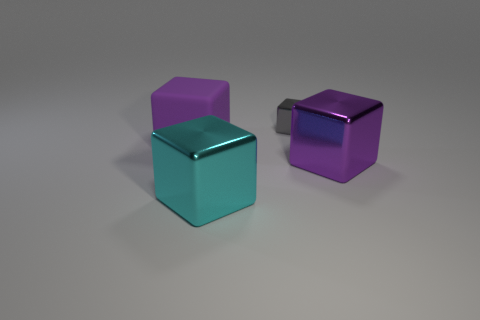Subtract all purple blocks. How many were subtracted if there are1purple blocks left? 1 Subtract 1 cubes. How many cubes are left? 3 Subtract all green blocks. Subtract all blue spheres. How many blocks are left? 4 Subtract all purple cylinders. How many purple blocks are left? 2 Subtract all cyan metallic cylinders. Subtract all large purple metal objects. How many objects are left? 3 Add 3 metallic cubes. How many metallic cubes are left? 6 Add 2 small red metal objects. How many small red metal objects exist? 2 Add 1 cyan metal blocks. How many objects exist? 5 Subtract all gray blocks. How many blocks are left? 3 Subtract all big purple rubber cubes. How many cubes are left? 3 